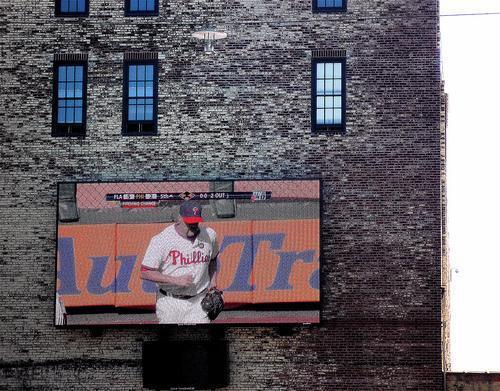How many windows are there?
Give a very brief answer. 6. How many people are in this picture?
Give a very brief answer. 1. 